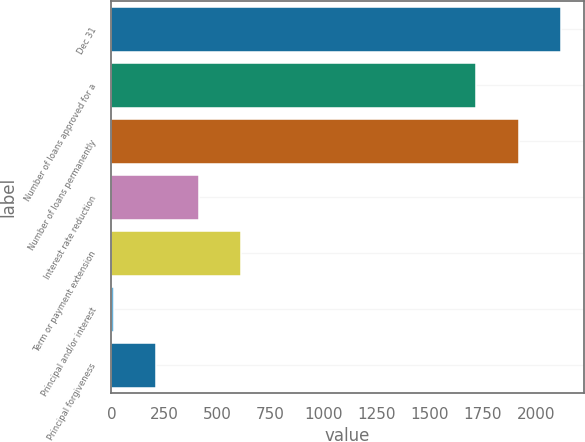Convert chart. <chart><loc_0><loc_0><loc_500><loc_500><bar_chart><fcel>Dec 31<fcel>Number of loans approved for a<fcel>Number of loans permanently<fcel>Interest rate reduction<fcel>Term or payment extension<fcel>Principal and/or interest<fcel>Principal forgiveness<nl><fcel>2119.2<fcel>1719<fcel>1919.1<fcel>412.2<fcel>612.3<fcel>12<fcel>212.1<nl></chart> 